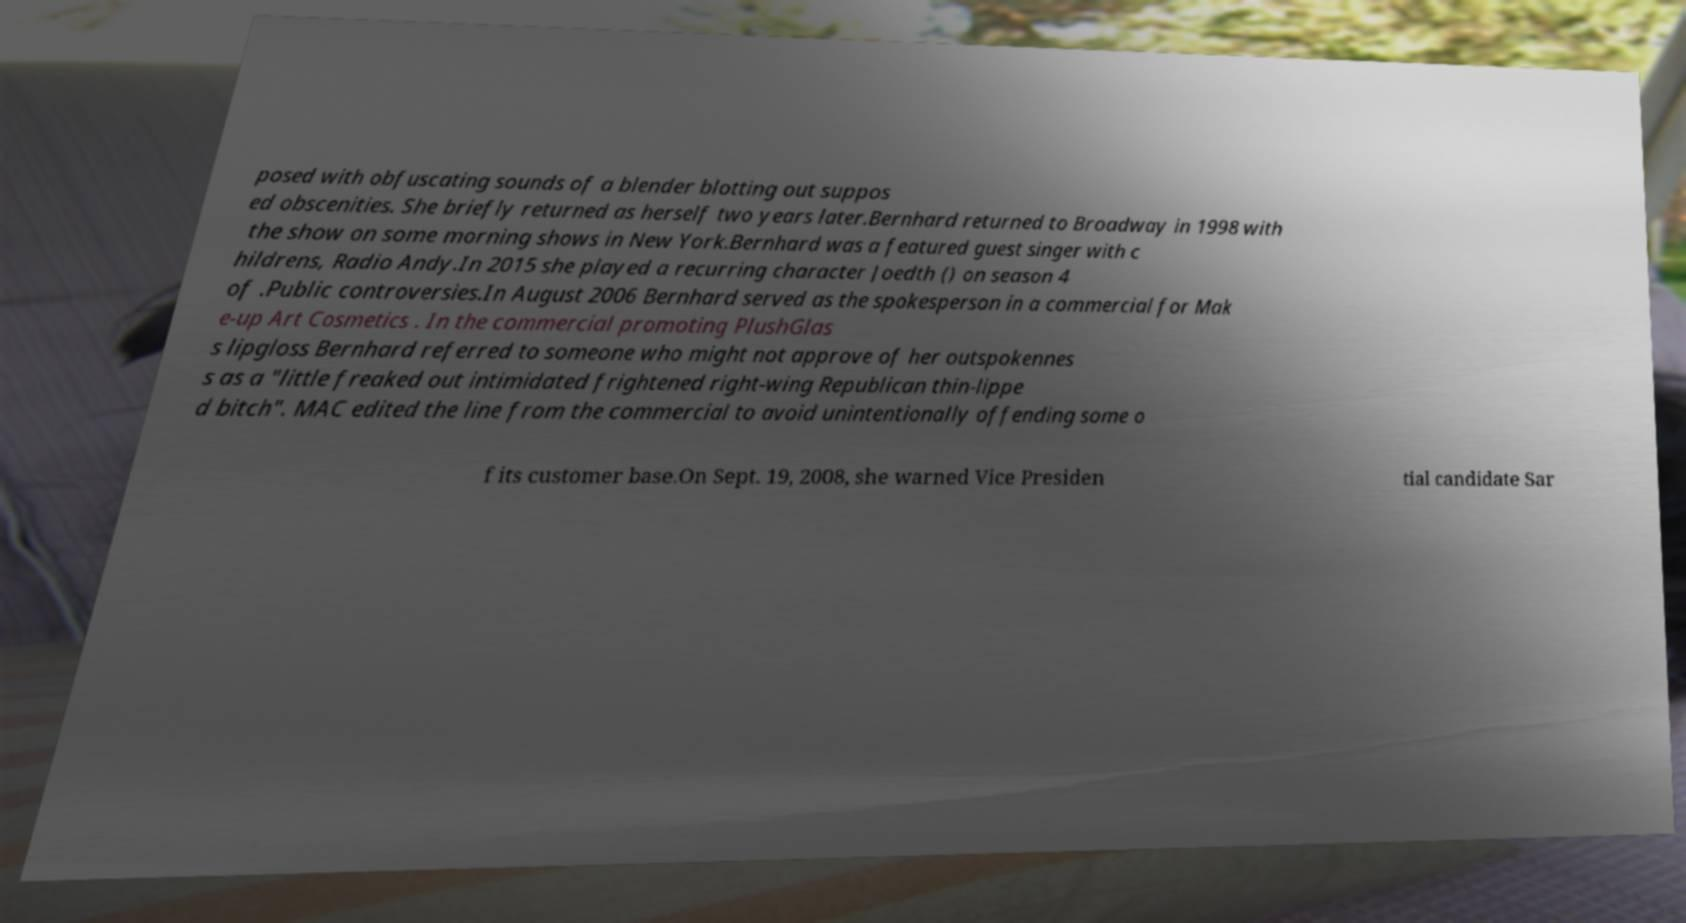Can you accurately transcribe the text from the provided image for me? posed with obfuscating sounds of a blender blotting out suppos ed obscenities. She briefly returned as herself two years later.Bernhard returned to Broadway in 1998 with the show on some morning shows in New York.Bernhard was a featured guest singer with c hildrens, Radio Andy.In 2015 she played a recurring character Joedth () on season 4 of .Public controversies.In August 2006 Bernhard served as the spokesperson in a commercial for Mak e-up Art Cosmetics . In the commercial promoting PlushGlas s lipgloss Bernhard referred to someone who might not approve of her outspokennes s as a "little freaked out intimidated frightened right-wing Republican thin-lippe d bitch". MAC edited the line from the commercial to avoid unintentionally offending some o f its customer base.On Sept. 19, 2008, she warned Vice Presiden tial candidate Sar 